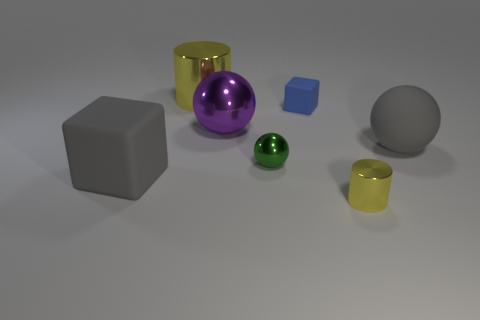Add 3 metal balls. How many objects exist? 10 Subtract all cylinders. How many objects are left? 5 Subtract 0 purple cylinders. How many objects are left? 7 Subtract all gray spheres. Subtract all large gray things. How many objects are left? 4 Add 4 large balls. How many large balls are left? 6 Add 7 blue things. How many blue things exist? 8 